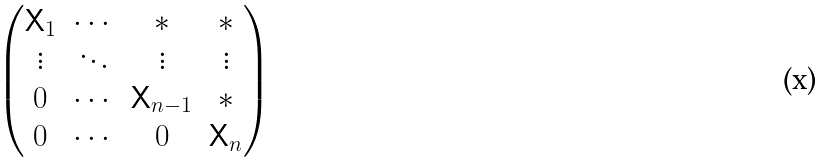Convert formula to latex. <formula><loc_0><loc_0><loc_500><loc_500>\begin{pmatrix} \mathsf X _ { 1 } & \cdots & * & * \\ \vdots & \ddots & \vdots & \vdots \\ 0 & \cdots & \mathsf X _ { n - 1 } & * \\ 0 & \cdots & 0 & \mathsf X _ { n } \end{pmatrix}</formula> 